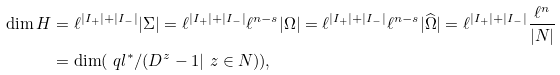<formula> <loc_0><loc_0><loc_500><loc_500>\dim H & = \ell ^ { | I _ { + } | + | I _ { - } | } | \Sigma | = \ell ^ { | I _ { + } | + | I _ { - } | } \ell ^ { n - s } | \Omega | = \ell ^ { | I _ { + } | + | I _ { - } | } \ell ^ { n - s } | \widehat { \Omega } | = \ell ^ { | I _ { + } | + | I _ { - } | } \frac { \ell ^ { n } } { | N | } \\ & = \dim ( \ q l ^ { * } / ( D ^ { z } - 1 | \ z \in N ) ) ,</formula> 